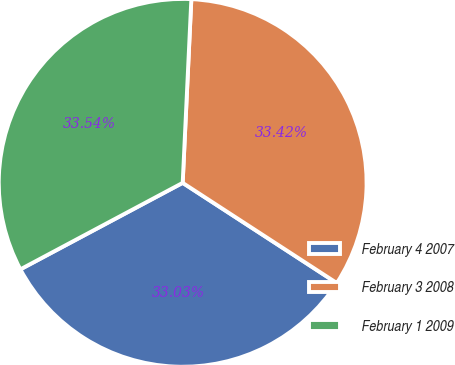Convert chart. <chart><loc_0><loc_0><loc_500><loc_500><pie_chart><fcel>February 4 2007<fcel>February 3 2008<fcel>February 1 2009<nl><fcel>33.03%<fcel>33.42%<fcel>33.54%<nl></chart> 